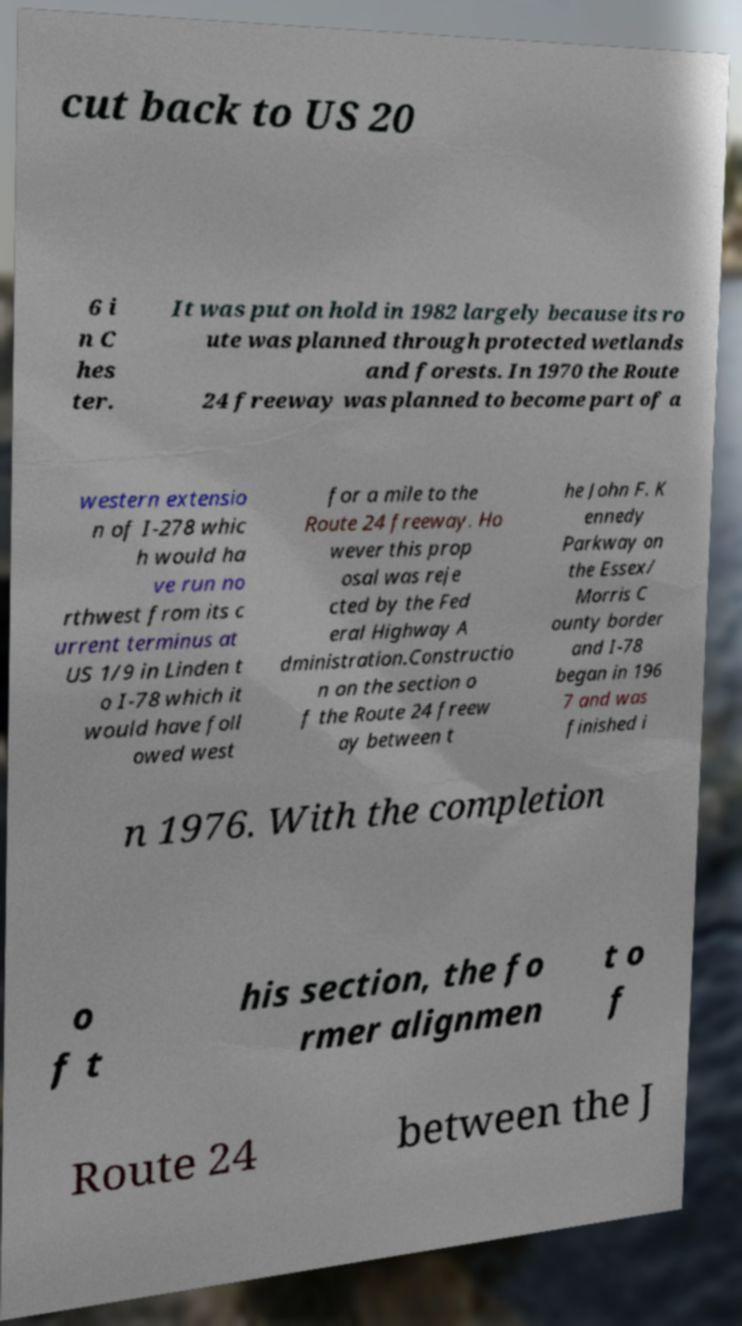For documentation purposes, I need the text within this image transcribed. Could you provide that? cut back to US 20 6 i n C hes ter. It was put on hold in 1982 largely because its ro ute was planned through protected wetlands and forests. In 1970 the Route 24 freeway was planned to become part of a western extensio n of I-278 whic h would ha ve run no rthwest from its c urrent terminus at US 1/9 in Linden t o I-78 which it would have foll owed west for a mile to the Route 24 freeway. Ho wever this prop osal was reje cted by the Fed eral Highway A dministration.Constructio n on the section o f the Route 24 freew ay between t he John F. K ennedy Parkway on the Essex/ Morris C ounty border and I-78 began in 196 7 and was finished i n 1976. With the completion o f t his section, the fo rmer alignmen t o f Route 24 between the J 